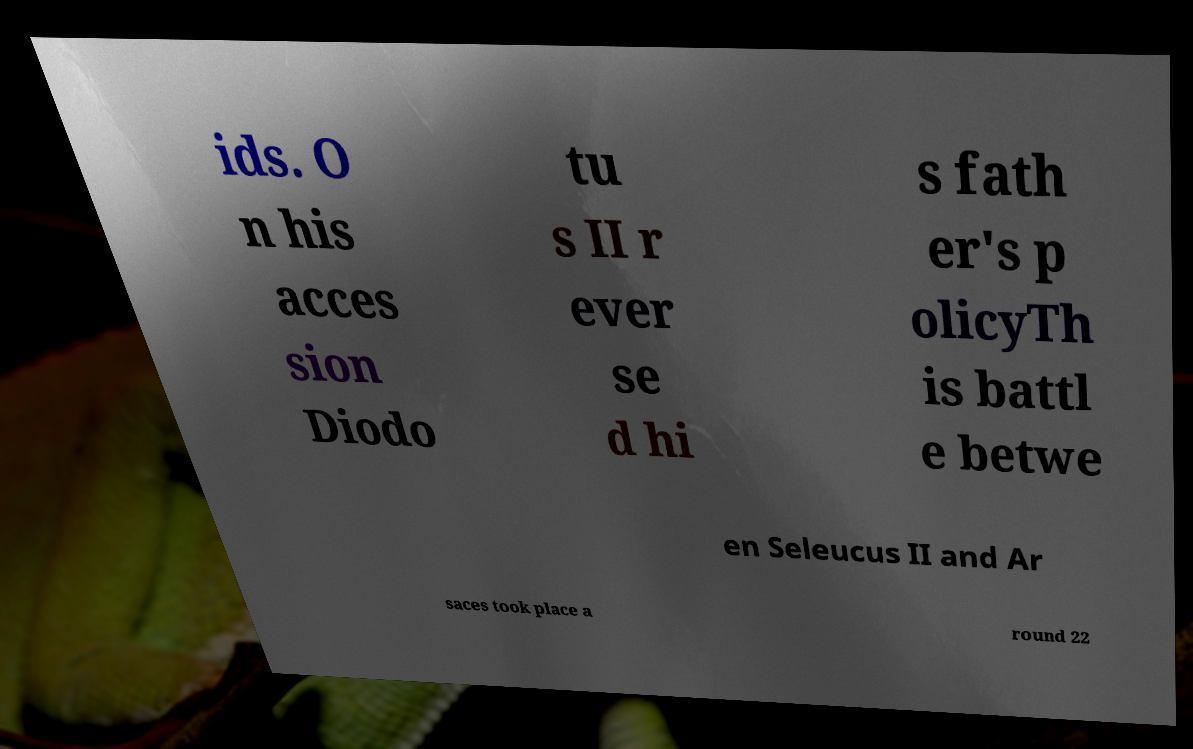I need the written content from this picture converted into text. Can you do that? ids. O n his acces sion Diodo tu s II r ever se d hi s fath er's p olicyTh is battl e betwe en Seleucus II and Ar saces took place a round 22 